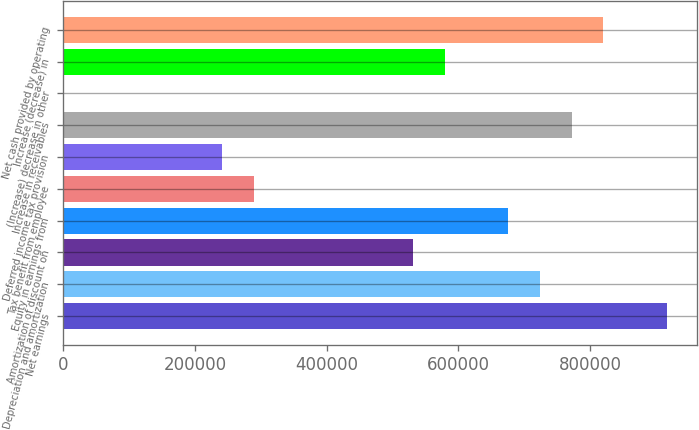Convert chart. <chart><loc_0><loc_0><loc_500><loc_500><bar_chart><fcel>Net earnings<fcel>Depreciation and amortization<fcel>Amortization of discount on<fcel>Equity in earnings from<fcel>Tax benefit from employee<fcel>Deferred income tax provision<fcel>Increase in receivables<fcel>(Increase) decrease in other<fcel>Increase (decrease) in<fcel>Net cash provided by operating<nl><fcel>916399<fcel>723483<fcel>530567<fcel>675254<fcel>289422<fcel>241193<fcel>771712<fcel>48<fcel>578796<fcel>819941<nl></chart> 